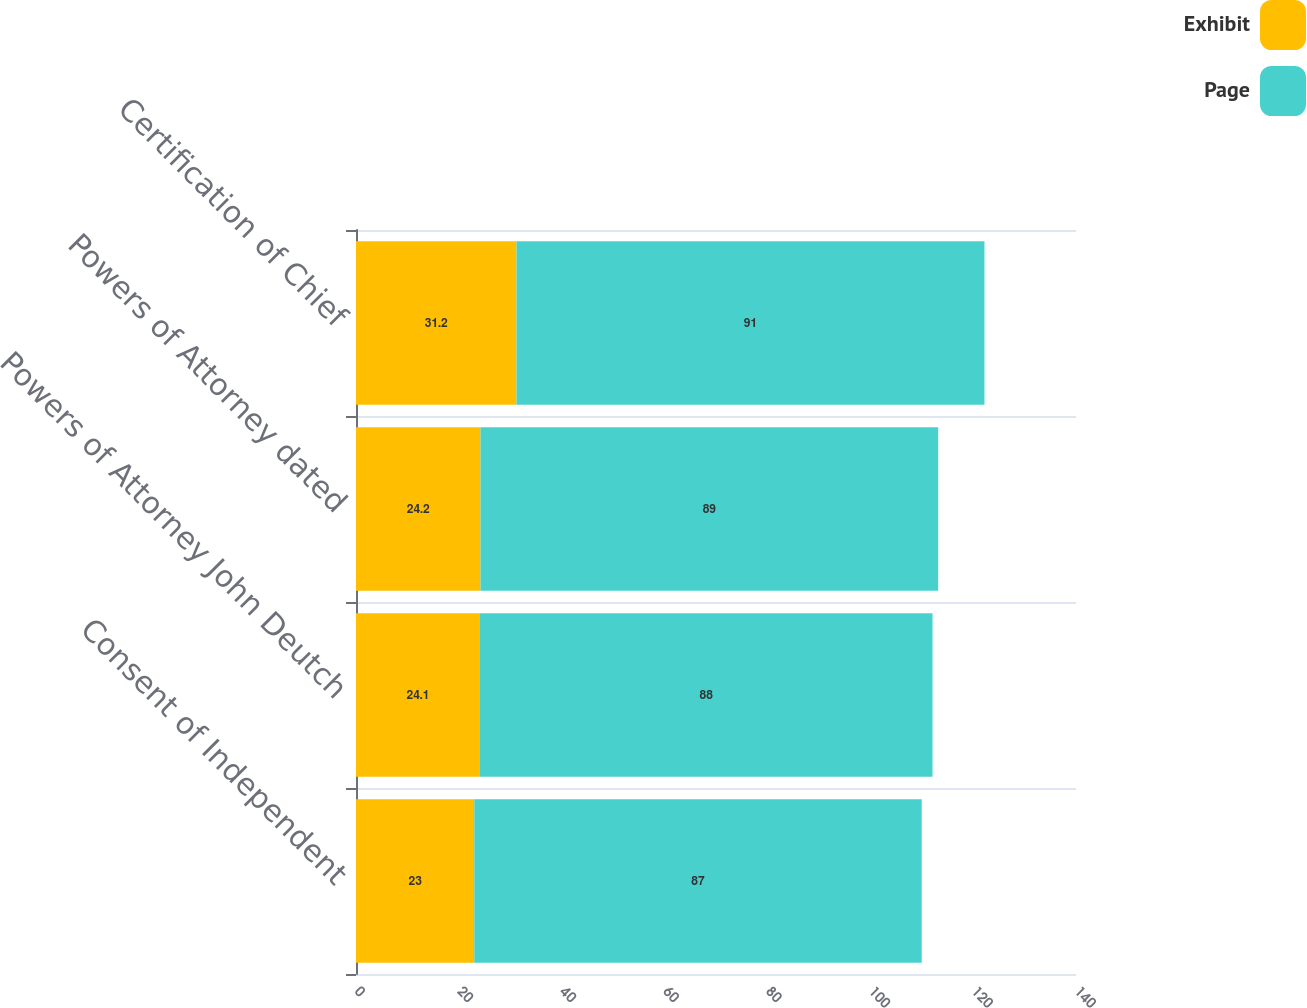Convert chart. <chart><loc_0><loc_0><loc_500><loc_500><stacked_bar_chart><ecel><fcel>Consent of Independent<fcel>Powers of Attorney John Deutch<fcel>Powers of Attorney dated<fcel>Certification of Chief<nl><fcel>Exhibit<fcel>23<fcel>24.1<fcel>24.2<fcel>31.2<nl><fcel>Page<fcel>87<fcel>88<fcel>89<fcel>91<nl></chart> 